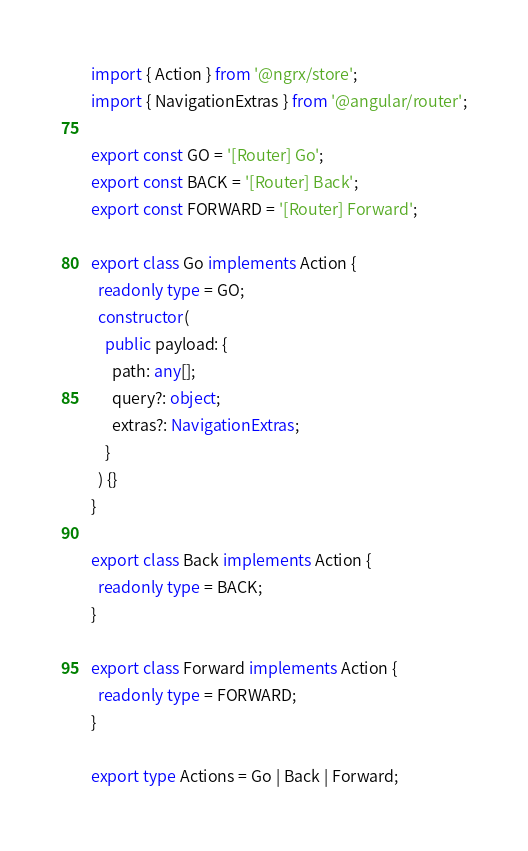Convert code to text. <code><loc_0><loc_0><loc_500><loc_500><_TypeScript_>import { Action } from '@ngrx/store';
import { NavigationExtras } from '@angular/router';

export const GO = '[Router] Go';
export const BACK = '[Router] Back';
export const FORWARD = '[Router] Forward';

export class Go implements Action {
  readonly type = GO;
  constructor(
    public payload: {
      path: any[];
      query?: object;
      extras?: NavigationExtras;
    }
  ) {}
}

export class Back implements Action {
  readonly type = BACK;
}

export class Forward implements Action {
  readonly type = FORWARD;
}

export type Actions = Go | Back | Forward;
</code> 